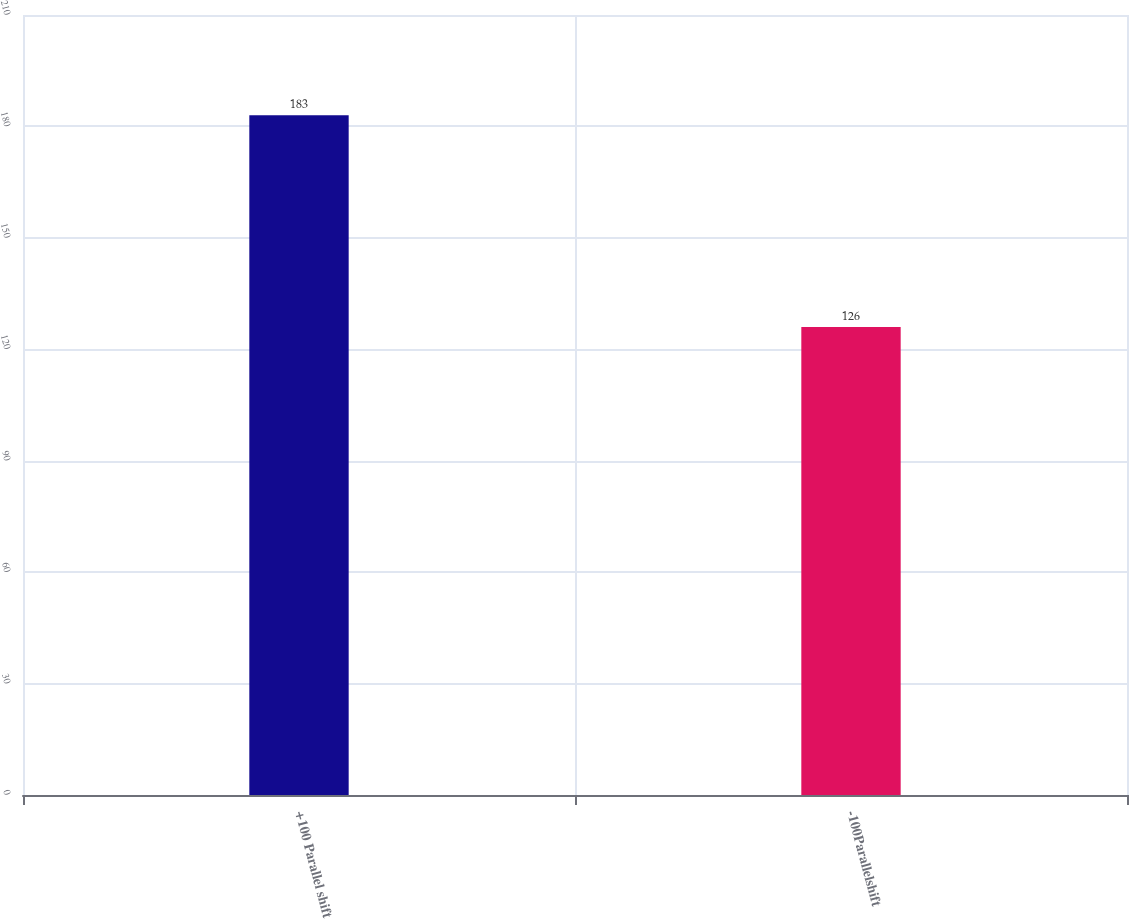<chart> <loc_0><loc_0><loc_500><loc_500><bar_chart><fcel>+100 Parallel shift<fcel>-100Parallelshift<nl><fcel>183<fcel>126<nl></chart> 